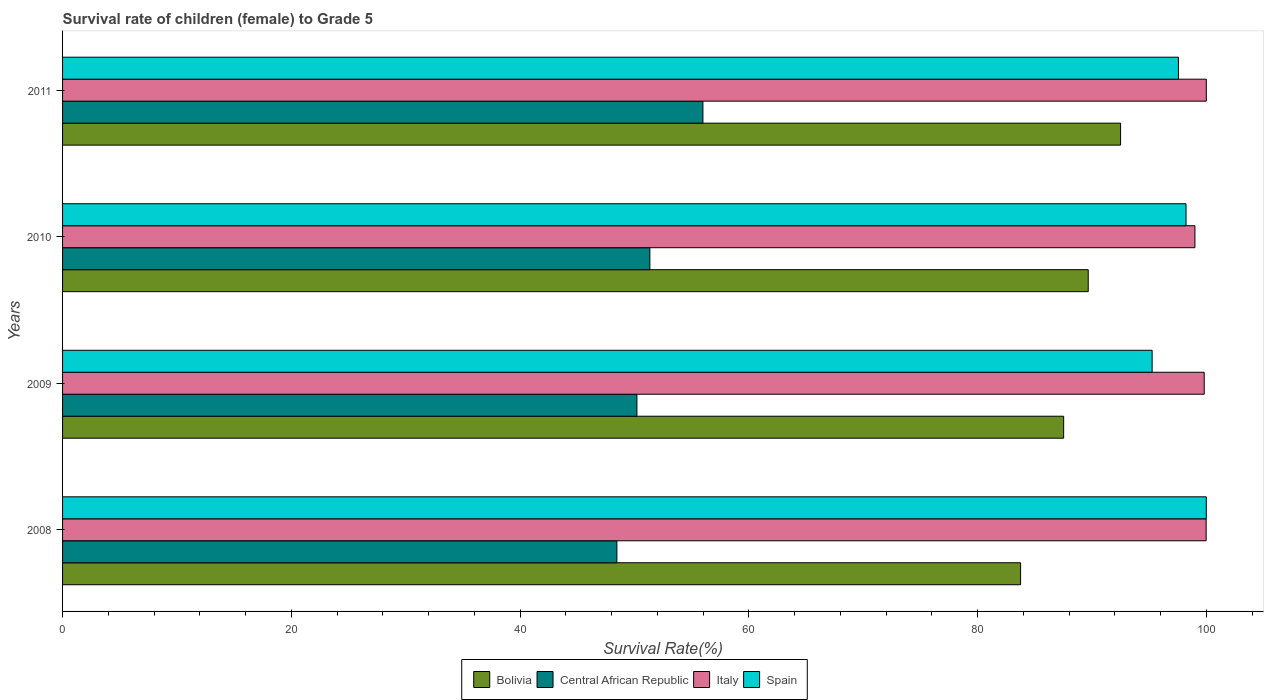How many groups of bars are there?
Keep it short and to the point. 4. Are the number of bars per tick equal to the number of legend labels?
Give a very brief answer. Yes. How many bars are there on the 2nd tick from the bottom?
Your answer should be very brief. 4. What is the label of the 3rd group of bars from the top?
Your answer should be compact. 2009. What is the survival rate of female children to grade 5 in Italy in 2011?
Offer a terse response. 100. Across all years, what is the minimum survival rate of female children to grade 5 in Spain?
Your response must be concise. 95.26. In which year was the survival rate of female children to grade 5 in Italy minimum?
Keep it short and to the point. 2010. What is the total survival rate of female children to grade 5 in Bolivia in the graph?
Offer a very short reply. 353.47. What is the difference between the survival rate of female children to grade 5 in Central African Republic in 2009 and that in 2011?
Provide a short and direct response. -5.77. What is the difference between the survival rate of female children to grade 5 in Spain in 2010 and the survival rate of female children to grade 5 in Bolivia in 2011?
Provide a succinct answer. 5.72. What is the average survival rate of female children to grade 5 in Italy per year?
Your answer should be compact. 99.7. In the year 2009, what is the difference between the survival rate of female children to grade 5 in Spain and survival rate of female children to grade 5 in Central African Republic?
Provide a succinct answer. 45.05. In how many years, is the survival rate of female children to grade 5 in Bolivia greater than 68 %?
Give a very brief answer. 4. What is the ratio of the survival rate of female children to grade 5 in Bolivia in 2008 to that in 2011?
Your answer should be very brief. 0.91. Is the survival rate of female children to grade 5 in Spain in 2009 less than that in 2011?
Your answer should be very brief. Yes. What is the difference between the highest and the second highest survival rate of female children to grade 5 in Central African Republic?
Offer a terse response. 4.64. What is the difference between the highest and the lowest survival rate of female children to grade 5 in Italy?
Keep it short and to the point. 0.99. Is it the case that in every year, the sum of the survival rate of female children to grade 5 in Spain and survival rate of female children to grade 5 in Central African Republic is greater than the sum of survival rate of female children to grade 5 in Italy and survival rate of female children to grade 5 in Bolivia?
Provide a succinct answer. Yes. What does the 1st bar from the top in 2008 represents?
Offer a very short reply. Spain. Is it the case that in every year, the sum of the survival rate of female children to grade 5 in Spain and survival rate of female children to grade 5 in Central African Republic is greater than the survival rate of female children to grade 5 in Bolivia?
Provide a short and direct response. Yes. How many bars are there?
Your answer should be compact. 16. How many years are there in the graph?
Provide a short and direct response. 4. Does the graph contain grids?
Ensure brevity in your answer.  No. How many legend labels are there?
Keep it short and to the point. 4. What is the title of the graph?
Make the answer very short. Survival rate of children (female) to Grade 5. What is the label or title of the X-axis?
Make the answer very short. Survival Rate(%). What is the label or title of the Y-axis?
Ensure brevity in your answer.  Years. What is the Survival Rate(%) in Bolivia in 2008?
Make the answer very short. 83.76. What is the Survival Rate(%) in Central African Republic in 2008?
Offer a terse response. 48.47. What is the Survival Rate(%) in Italy in 2008?
Your answer should be compact. 99.99. What is the Survival Rate(%) in Spain in 2008?
Ensure brevity in your answer.  100. What is the Survival Rate(%) in Bolivia in 2009?
Your answer should be compact. 87.53. What is the Survival Rate(%) of Central African Republic in 2009?
Your answer should be compact. 50.22. What is the Survival Rate(%) of Italy in 2009?
Give a very brief answer. 99.82. What is the Survival Rate(%) in Spain in 2009?
Provide a short and direct response. 95.26. What is the Survival Rate(%) in Bolivia in 2010?
Provide a short and direct response. 89.68. What is the Survival Rate(%) in Central African Republic in 2010?
Offer a terse response. 51.35. What is the Survival Rate(%) in Italy in 2010?
Your response must be concise. 99.01. What is the Survival Rate(%) of Spain in 2010?
Offer a terse response. 98.23. What is the Survival Rate(%) of Bolivia in 2011?
Your response must be concise. 92.5. What is the Survival Rate(%) in Central African Republic in 2011?
Your answer should be very brief. 55.99. What is the Survival Rate(%) of Italy in 2011?
Ensure brevity in your answer.  100. What is the Survival Rate(%) in Spain in 2011?
Provide a short and direct response. 97.56. Across all years, what is the maximum Survival Rate(%) of Bolivia?
Keep it short and to the point. 92.5. Across all years, what is the maximum Survival Rate(%) in Central African Republic?
Your answer should be compact. 55.99. Across all years, what is the maximum Survival Rate(%) of Spain?
Keep it short and to the point. 100. Across all years, what is the minimum Survival Rate(%) in Bolivia?
Keep it short and to the point. 83.76. Across all years, what is the minimum Survival Rate(%) in Central African Republic?
Provide a succinct answer. 48.47. Across all years, what is the minimum Survival Rate(%) in Italy?
Make the answer very short. 99.01. Across all years, what is the minimum Survival Rate(%) in Spain?
Your answer should be very brief. 95.26. What is the total Survival Rate(%) of Bolivia in the graph?
Provide a short and direct response. 353.47. What is the total Survival Rate(%) in Central African Republic in the graph?
Ensure brevity in your answer.  206.02. What is the total Survival Rate(%) of Italy in the graph?
Ensure brevity in your answer.  398.81. What is the total Survival Rate(%) in Spain in the graph?
Offer a terse response. 391.05. What is the difference between the Survival Rate(%) of Bolivia in 2008 and that in 2009?
Your answer should be very brief. -3.77. What is the difference between the Survival Rate(%) of Central African Republic in 2008 and that in 2009?
Offer a very short reply. -1.75. What is the difference between the Survival Rate(%) in Italy in 2008 and that in 2009?
Your answer should be very brief. 0.17. What is the difference between the Survival Rate(%) of Spain in 2008 and that in 2009?
Keep it short and to the point. 4.73. What is the difference between the Survival Rate(%) in Bolivia in 2008 and that in 2010?
Your answer should be compact. -5.91. What is the difference between the Survival Rate(%) in Central African Republic in 2008 and that in 2010?
Keep it short and to the point. -2.88. What is the difference between the Survival Rate(%) in Italy in 2008 and that in 2010?
Your answer should be compact. 0.98. What is the difference between the Survival Rate(%) in Spain in 2008 and that in 2010?
Make the answer very short. 1.77. What is the difference between the Survival Rate(%) in Bolivia in 2008 and that in 2011?
Your response must be concise. -8.74. What is the difference between the Survival Rate(%) of Central African Republic in 2008 and that in 2011?
Your answer should be compact. -7.52. What is the difference between the Survival Rate(%) of Italy in 2008 and that in 2011?
Make the answer very short. -0.01. What is the difference between the Survival Rate(%) in Spain in 2008 and that in 2011?
Give a very brief answer. 2.43. What is the difference between the Survival Rate(%) of Bolivia in 2009 and that in 2010?
Provide a succinct answer. -2.15. What is the difference between the Survival Rate(%) in Central African Republic in 2009 and that in 2010?
Offer a terse response. -1.13. What is the difference between the Survival Rate(%) of Italy in 2009 and that in 2010?
Offer a very short reply. 0.81. What is the difference between the Survival Rate(%) of Spain in 2009 and that in 2010?
Ensure brevity in your answer.  -2.96. What is the difference between the Survival Rate(%) in Bolivia in 2009 and that in 2011?
Provide a succinct answer. -4.98. What is the difference between the Survival Rate(%) in Central African Republic in 2009 and that in 2011?
Your response must be concise. -5.77. What is the difference between the Survival Rate(%) in Italy in 2009 and that in 2011?
Your response must be concise. -0.18. What is the difference between the Survival Rate(%) of Spain in 2009 and that in 2011?
Your response must be concise. -2.3. What is the difference between the Survival Rate(%) of Bolivia in 2010 and that in 2011?
Provide a short and direct response. -2.83. What is the difference between the Survival Rate(%) of Central African Republic in 2010 and that in 2011?
Your answer should be very brief. -4.64. What is the difference between the Survival Rate(%) of Italy in 2010 and that in 2011?
Ensure brevity in your answer.  -0.99. What is the difference between the Survival Rate(%) in Spain in 2010 and that in 2011?
Your answer should be very brief. 0.66. What is the difference between the Survival Rate(%) of Bolivia in 2008 and the Survival Rate(%) of Central African Republic in 2009?
Keep it short and to the point. 33.55. What is the difference between the Survival Rate(%) of Bolivia in 2008 and the Survival Rate(%) of Italy in 2009?
Offer a terse response. -16.05. What is the difference between the Survival Rate(%) of Bolivia in 2008 and the Survival Rate(%) of Spain in 2009?
Make the answer very short. -11.5. What is the difference between the Survival Rate(%) of Central African Republic in 2008 and the Survival Rate(%) of Italy in 2009?
Provide a short and direct response. -51.35. What is the difference between the Survival Rate(%) of Central African Republic in 2008 and the Survival Rate(%) of Spain in 2009?
Ensure brevity in your answer.  -46.8. What is the difference between the Survival Rate(%) in Italy in 2008 and the Survival Rate(%) in Spain in 2009?
Offer a very short reply. 4.72. What is the difference between the Survival Rate(%) in Bolivia in 2008 and the Survival Rate(%) in Central African Republic in 2010?
Offer a very short reply. 32.41. What is the difference between the Survival Rate(%) of Bolivia in 2008 and the Survival Rate(%) of Italy in 2010?
Keep it short and to the point. -15.24. What is the difference between the Survival Rate(%) of Bolivia in 2008 and the Survival Rate(%) of Spain in 2010?
Your answer should be very brief. -14.47. What is the difference between the Survival Rate(%) in Central African Republic in 2008 and the Survival Rate(%) in Italy in 2010?
Your response must be concise. -50.54. What is the difference between the Survival Rate(%) in Central African Republic in 2008 and the Survival Rate(%) in Spain in 2010?
Your answer should be very brief. -49.76. What is the difference between the Survival Rate(%) of Italy in 2008 and the Survival Rate(%) of Spain in 2010?
Your response must be concise. 1.76. What is the difference between the Survival Rate(%) in Bolivia in 2008 and the Survival Rate(%) in Central African Republic in 2011?
Your response must be concise. 27.77. What is the difference between the Survival Rate(%) of Bolivia in 2008 and the Survival Rate(%) of Italy in 2011?
Provide a short and direct response. -16.24. What is the difference between the Survival Rate(%) in Bolivia in 2008 and the Survival Rate(%) in Spain in 2011?
Offer a very short reply. -13.8. What is the difference between the Survival Rate(%) in Central African Republic in 2008 and the Survival Rate(%) in Italy in 2011?
Give a very brief answer. -51.53. What is the difference between the Survival Rate(%) of Central African Republic in 2008 and the Survival Rate(%) of Spain in 2011?
Your answer should be very brief. -49.1. What is the difference between the Survival Rate(%) of Italy in 2008 and the Survival Rate(%) of Spain in 2011?
Your response must be concise. 2.42. What is the difference between the Survival Rate(%) in Bolivia in 2009 and the Survival Rate(%) in Central African Republic in 2010?
Offer a very short reply. 36.18. What is the difference between the Survival Rate(%) in Bolivia in 2009 and the Survival Rate(%) in Italy in 2010?
Keep it short and to the point. -11.48. What is the difference between the Survival Rate(%) of Bolivia in 2009 and the Survival Rate(%) of Spain in 2010?
Your answer should be very brief. -10.7. What is the difference between the Survival Rate(%) of Central African Republic in 2009 and the Survival Rate(%) of Italy in 2010?
Make the answer very short. -48.79. What is the difference between the Survival Rate(%) in Central African Republic in 2009 and the Survival Rate(%) in Spain in 2010?
Keep it short and to the point. -48.01. What is the difference between the Survival Rate(%) of Italy in 2009 and the Survival Rate(%) of Spain in 2010?
Make the answer very short. 1.59. What is the difference between the Survival Rate(%) of Bolivia in 2009 and the Survival Rate(%) of Central African Republic in 2011?
Offer a terse response. 31.54. What is the difference between the Survival Rate(%) in Bolivia in 2009 and the Survival Rate(%) in Italy in 2011?
Your answer should be compact. -12.47. What is the difference between the Survival Rate(%) in Bolivia in 2009 and the Survival Rate(%) in Spain in 2011?
Ensure brevity in your answer.  -10.04. What is the difference between the Survival Rate(%) of Central African Republic in 2009 and the Survival Rate(%) of Italy in 2011?
Provide a short and direct response. -49.78. What is the difference between the Survival Rate(%) of Central African Republic in 2009 and the Survival Rate(%) of Spain in 2011?
Your response must be concise. -47.35. What is the difference between the Survival Rate(%) of Italy in 2009 and the Survival Rate(%) of Spain in 2011?
Make the answer very short. 2.25. What is the difference between the Survival Rate(%) in Bolivia in 2010 and the Survival Rate(%) in Central African Republic in 2011?
Ensure brevity in your answer.  33.69. What is the difference between the Survival Rate(%) of Bolivia in 2010 and the Survival Rate(%) of Italy in 2011?
Provide a short and direct response. -10.32. What is the difference between the Survival Rate(%) of Bolivia in 2010 and the Survival Rate(%) of Spain in 2011?
Make the answer very short. -7.89. What is the difference between the Survival Rate(%) in Central African Republic in 2010 and the Survival Rate(%) in Italy in 2011?
Ensure brevity in your answer.  -48.65. What is the difference between the Survival Rate(%) in Central African Republic in 2010 and the Survival Rate(%) in Spain in 2011?
Give a very brief answer. -46.21. What is the difference between the Survival Rate(%) in Italy in 2010 and the Survival Rate(%) in Spain in 2011?
Offer a terse response. 1.44. What is the average Survival Rate(%) of Bolivia per year?
Your response must be concise. 88.37. What is the average Survival Rate(%) in Central African Republic per year?
Ensure brevity in your answer.  51.51. What is the average Survival Rate(%) of Italy per year?
Your answer should be very brief. 99.7. What is the average Survival Rate(%) in Spain per year?
Provide a short and direct response. 97.76. In the year 2008, what is the difference between the Survival Rate(%) in Bolivia and Survival Rate(%) in Central African Republic?
Your answer should be very brief. 35.3. In the year 2008, what is the difference between the Survival Rate(%) of Bolivia and Survival Rate(%) of Italy?
Offer a very short reply. -16.22. In the year 2008, what is the difference between the Survival Rate(%) of Bolivia and Survival Rate(%) of Spain?
Keep it short and to the point. -16.24. In the year 2008, what is the difference between the Survival Rate(%) of Central African Republic and Survival Rate(%) of Italy?
Keep it short and to the point. -51.52. In the year 2008, what is the difference between the Survival Rate(%) of Central African Republic and Survival Rate(%) of Spain?
Your answer should be very brief. -51.53. In the year 2008, what is the difference between the Survival Rate(%) of Italy and Survival Rate(%) of Spain?
Provide a succinct answer. -0.01. In the year 2009, what is the difference between the Survival Rate(%) of Bolivia and Survival Rate(%) of Central African Republic?
Offer a terse response. 37.31. In the year 2009, what is the difference between the Survival Rate(%) in Bolivia and Survival Rate(%) in Italy?
Make the answer very short. -12.29. In the year 2009, what is the difference between the Survival Rate(%) of Bolivia and Survival Rate(%) of Spain?
Your answer should be compact. -7.74. In the year 2009, what is the difference between the Survival Rate(%) of Central African Republic and Survival Rate(%) of Italy?
Your answer should be very brief. -49.6. In the year 2009, what is the difference between the Survival Rate(%) of Central African Republic and Survival Rate(%) of Spain?
Provide a short and direct response. -45.05. In the year 2009, what is the difference between the Survival Rate(%) in Italy and Survival Rate(%) in Spain?
Ensure brevity in your answer.  4.55. In the year 2010, what is the difference between the Survival Rate(%) of Bolivia and Survival Rate(%) of Central African Republic?
Your answer should be compact. 38.33. In the year 2010, what is the difference between the Survival Rate(%) in Bolivia and Survival Rate(%) in Italy?
Give a very brief answer. -9.33. In the year 2010, what is the difference between the Survival Rate(%) in Bolivia and Survival Rate(%) in Spain?
Your response must be concise. -8.55. In the year 2010, what is the difference between the Survival Rate(%) of Central African Republic and Survival Rate(%) of Italy?
Make the answer very short. -47.66. In the year 2010, what is the difference between the Survival Rate(%) in Central African Republic and Survival Rate(%) in Spain?
Ensure brevity in your answer.  -46.88. In the year 2010, what is the difference between the Survival Rate(%) in Italy and Survival Rate(%) in Spain?
Provide a succinct answer. 0.78. In the year 2011, what is the difference between the Survival Rate(%) of Bolivia and Survival Rate(%) of Central African Republic?
Provide a short and direct response. 36.52. In the year 2011, what is the difference between the Survival Rate(%) of Bolivia and Survival Rate(%) of Italy?
Give a very brief answer. -7.5. In the year 2011, what is the difference between the Survival Rate(%) in Bolivia and Survival Rate(%) in Spain?
Your response must be concise. -5.06. In the year 2011, what is the difference between the Survival Rate(%) in Central African Republic and Survival Rate(%) in Italy?
Offer a terse response. -44.01. In the year 2011, what is the difference between the Survival Rate(%) of Central African Republic and Survival Rate(%) of Spain?
Keep it short and to the point. -41.58. In the year 2011, what is the difference between the Survival Rate(%) in Italy and Survival Rate(%) in Spain?
Offer a terse response. 2.44. What is the ratio of the Survival Rate(%) in Bolivia in 2008 to that in 2009?
Your response must be concise. 0.96. What is the ratio of the Survival Rate(%) in Central African Republic in 2008 to that in 2009?
Offer a very short reply. 0.97. What is the ratio of the Survival Rate(%) of Spain in 2008 to that in 2009?
Offer a terse response. 1.05. What is the ratio of the Survival Rate(%) of Bolivia in 2008 to that in 2010?
Your answer should be compact. 0.93. What is the ratio of the Survival Rate(%) of Central African Republic in 2008 to that in 2010?
Make the answer very short. 0.94. What is the ratio of the Survival Rate(%) of Italy in 2008 to that in 2010?
Give a very brief answer. 1.01. What is the ratio of the Survival Rate(%) of Bolivia in 2008 to that in 2011?
Keep it short and to the point. 0.91. What is the ratio of the Survival Rate(%) of Central African Republic in 2008 to that in 2011?
Offer a very short reply. 0.87. What is the ratio of the Survival Rate(%) in Italy in 2008 to that in 2011?
Make the answer very short. 1. What is the ratio of the Survival Rate(%) in Spain in 2008 to that in 2011?
Give a very brief answer. 1.02. What is the ratio of the Survival Rate(%) of Bolivia in 2009 to that in 2010?
Your answer should be very brief. 0.98. What is the ratio of the Survival Rate(%) in Central African Republic in 2009 to that in 2010?
Your answer should be compact. 0.98. What is the ratio of the Survival Rate(%) in Italy in 2009 to that in 2010?
Your answer should be very brief. 1.01. What is the ratio of the Survival Rate(%) in Spain in 2009 to that in 2010?
Provide a succinct answer. 0.97. What is the ratio of the Survival Rate(%) of Bolivia in 2009 to that in 2011?
Provide a short and direct response. 0.95. What is the ratio of the Survival Rate(%) of Central African Republic in 2009 to that in 2011?
Ensure brevity in your answer.  0.9. What is the ratio of the Survival Rate(%) of Spain in 2009 to that in 2011?
Your response must be concise. 0.98. What is the ratio of the Survival Rate(%) of Bolivia in 2010 to that in 2011?
Provide a succinct answer. 0.97. What is the ratio of the Survival Rate(%) in Central African Republic in 2010 to that in 2011?
Make the answer very short. 0.92. What is the ratio of the Survival Rate(%) in Italy in 2010 to that in 2011?
Offer a terse response. 0.99. What is the ratio of the Survival Rate(%) of Spain in 2010 to that in 2011?
Offer a terse response. 1.01. What is the difference between the highest and the second highest Survival Rate(%) in Bolivia?
Ensure brevity in your answer.  2.83. What is the difference between the highest and the second highest Survival Rate(%) of Central African Republic?
Your answer should be very brief. 4.64. What is the difference between the highest and the second highest Survival Rate(%) of Italy?
Ensure brevity in your answer.  0.01. What is the difference between the highest and the second highest Survival Rate(%) in Spain?
Keep it short and to the point. 1.77. What is the difference between the highest and the lowest Survival Rate(%) of Bolivia?
Provide a succinct answer. 8.74. What is the difference between the highest and the lowest Survival Rate(%) in Central African Republic?
Your answer should be compact. 7.52. What is the difference between the highest and the lowest Survival Rate(%) of Italy?
Keep it short and to the point. 0.99. What is the difference between the highest and the lowest Survival Rate(%) in Spain?
Make the answer very short. 4.73. 